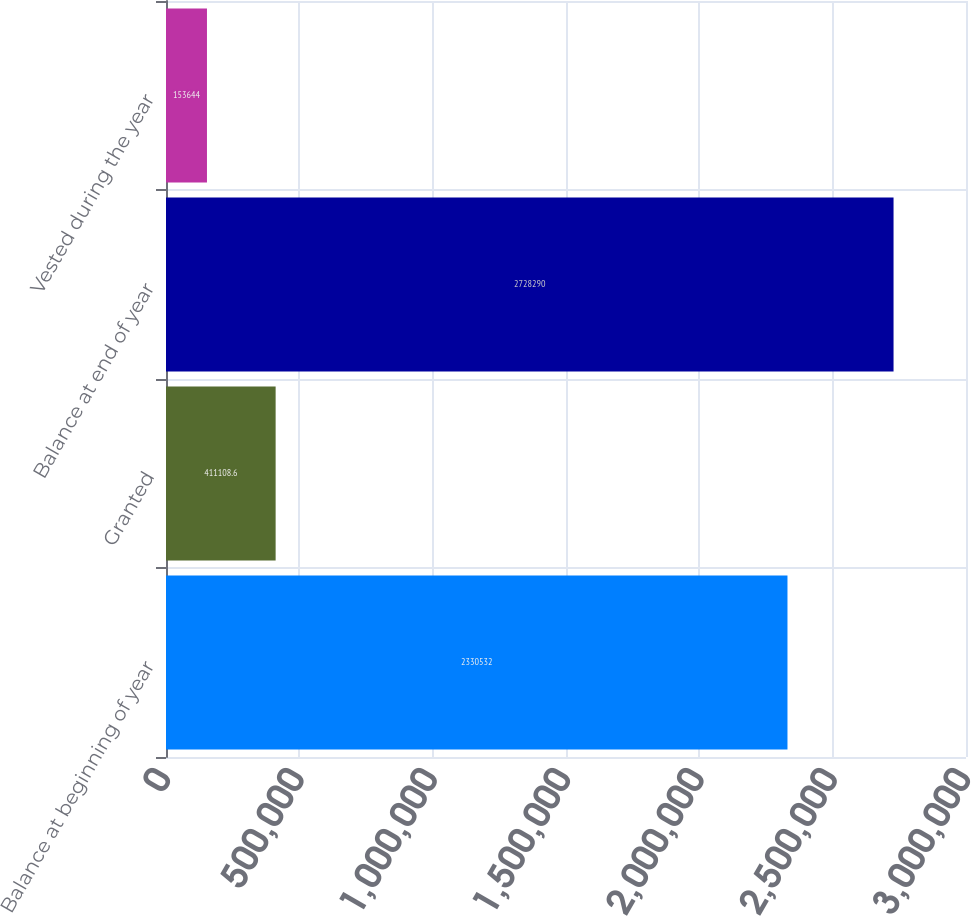Convert chart. <chart><loc_0><loc_0><loc_500><loc_500><bar_chart><fcel>Balance at beginning of year<fcel>Granted<fcel>Balance at end of year<fcel>Vested during the year<nl><fcel>2.33053e+06<fcel>411109<fcel>2.72829e+06<fcel>153644<nl></chart> 